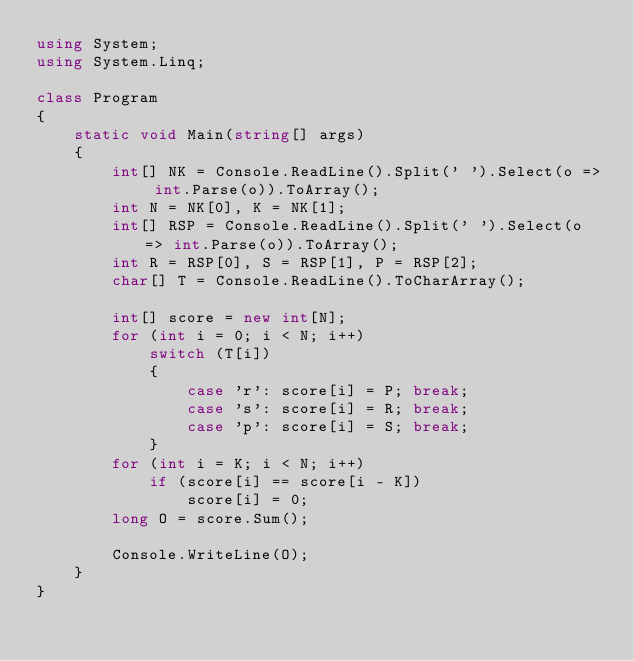<code> <loc_0><loc_0><loc_500><loc_500><_C#_>using System;
using System.Linq;

class Program
{
    static void Main(string[] args)
    {
        int[] NK = Console.ReadLine().Split(' ').Select(o => int.Parse(o)).ToArray();
        int N = NK[0], K = NK[1];
        int[] RSP = Console.ReadLine().Split(' ').Select(o => int.Parse(o)).ToArray();
        int R = RSP[0], S = RSP[1], P = RSP[2];
        char[] T = Console.ReadLine().ToCharArray();

        int[] score = new int[N];
        for (int i = 0; i < N; i++)
            switch (T[i])
            {
                case 'r': score[i] = P; break;
                case 's': score[i] = R; break;
                case 'p': score[i] = S; break;
            }
        for (int i = K; i < N; i++)
            if (score[i] == score[i - K])
                score[i] = 0;
        long O = score.Sum();

        Console.WriteLine(O);
    }
}
</code> 